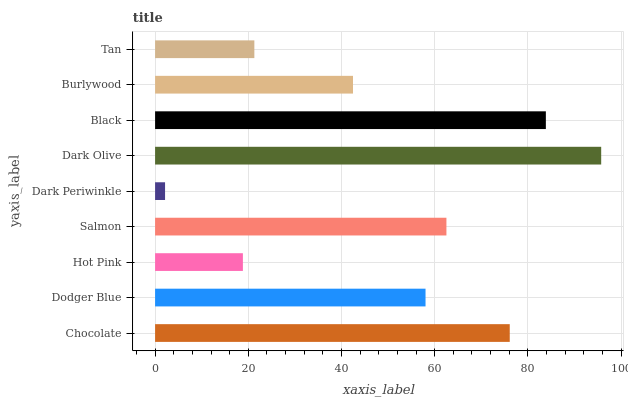Is Dark Periwinkle the minimum?
Answer yes or no. Yes. Is Dark Olive the maximum?
Answer yes or no. Yes. Is Dodger Blue the minimum?
Answer yes or no. No. Is Dodger Blue the maximum?
Answer yes or no. No. Is Chocolate greater than Dodger Blue?
Answer yes or no. Yes. Is Dodger Blue less than Chocolate?
Answer yes or no. Yes. Is Dodger Blue greater than Chocolate?
Answer yes or no. No. Is Chocolate less than Dodger Blue?
Answer yes or no. No. Is Dodger Blue the high median?
Answer yes or no. Yes. Is Dodger Blue the low median?
Answer yes or no. Yes. Is Chocolate the high median?
Answer yes or no. No. Is Black the low median?
Answer yes or no. No. 